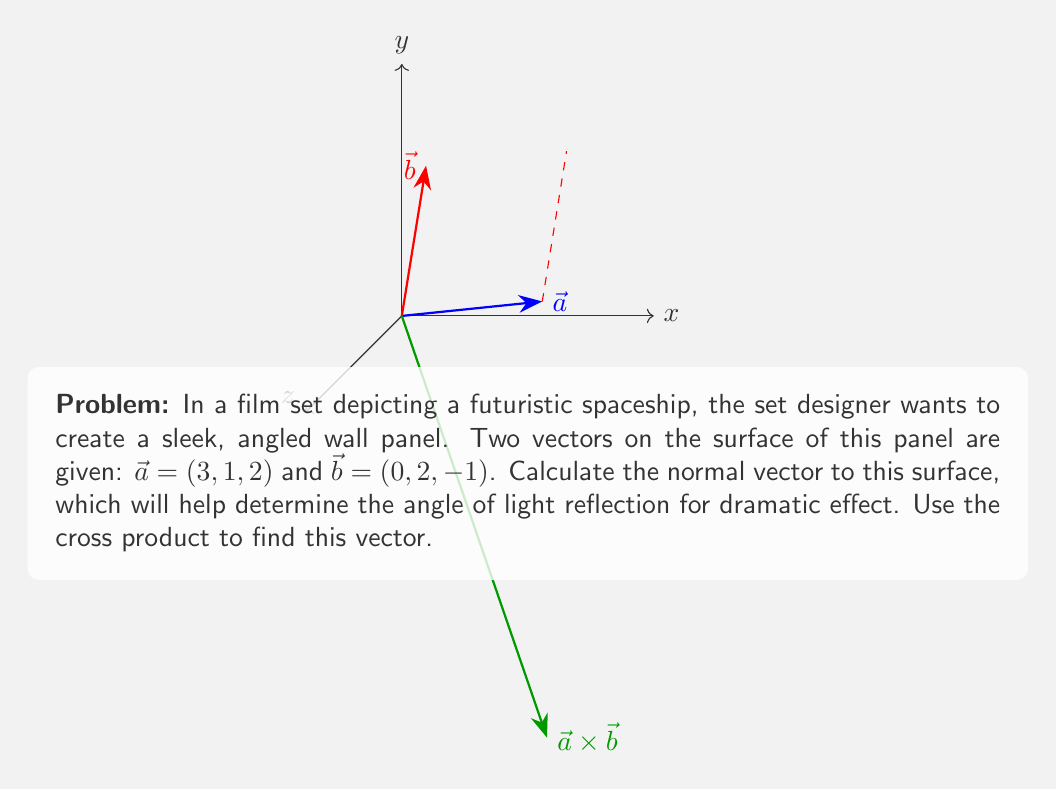Show me your answer to this math problem. To find the normal vector to the surface, we need to compute the cross product of the two given vectors $\vec{a}$ and $\vec{b}$. The cross product $\vec{a} \times \vec{b}$ will give us a vector perpendicular to both $\vec{a}$ and $\vec{b}$, which is the normal vector we're looking for.

The formula for the cross product of two vectors $\vec{a} = (a_1, a_2, a_3)$ and $\vec{b} = (b_1, b_2, b_3)$ is:

$$\vec{a} \times \vec{b} = (a_2b_3 - a_3b_2, a_3b_1 - a_1b_3, a_1b_2 - a_2b_1)$$

Let's substitute our values:
$\vec{a} = (3, 1, 2)$ and $\vec{b} = (0, 2, -1)$

1) Calculate the first component:
   $a_2b_3 - a_3b_2 = (1)(-1) - (2)(2) = -1 - 4 = -5$

2) Calculate the second component:
   $a_3b_1 - a_1b_3 = (2)(0) - (3)(-1) = 0 + 3 = 3$

3) Calculate the third component:
   $a_1b_2 - a_2b_1 = (3)(2) - (1)(0) = 6 - 0 = 6$

Therefore, the cross product $\vec{a} \times \vec{b} = (-5, 3, 6)$.

This vector $(-5, 3, 6)$ is normal to the surface of the wall panel in the film set. The set designer can use this information to determine how light will reflect off the surface, creating the desired dramatic effect for the futuristic spaceship scene.
Answer: $(-5, 3, 6)$ 